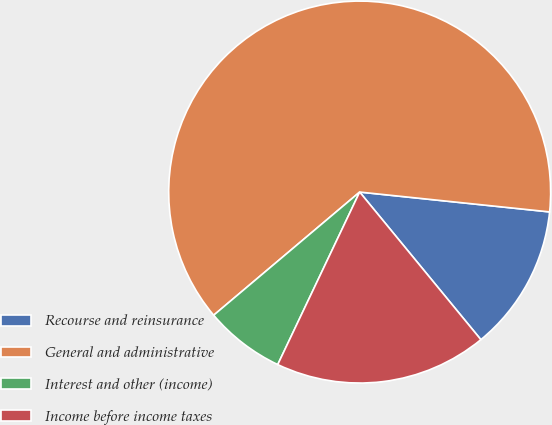Convert chart to OTSL. <chart><loc_0><loc_0><loc_500><loc_500><pie_chart><fcel>Recourse and reinsurance<fcel>General and administrative<fcel>Interest and other (income)<fcel>Income before income taxes<nl><fcel>12.4%<fcel>62.81%<fcel>6.79%<fcel>18.0%<nl></chart> 